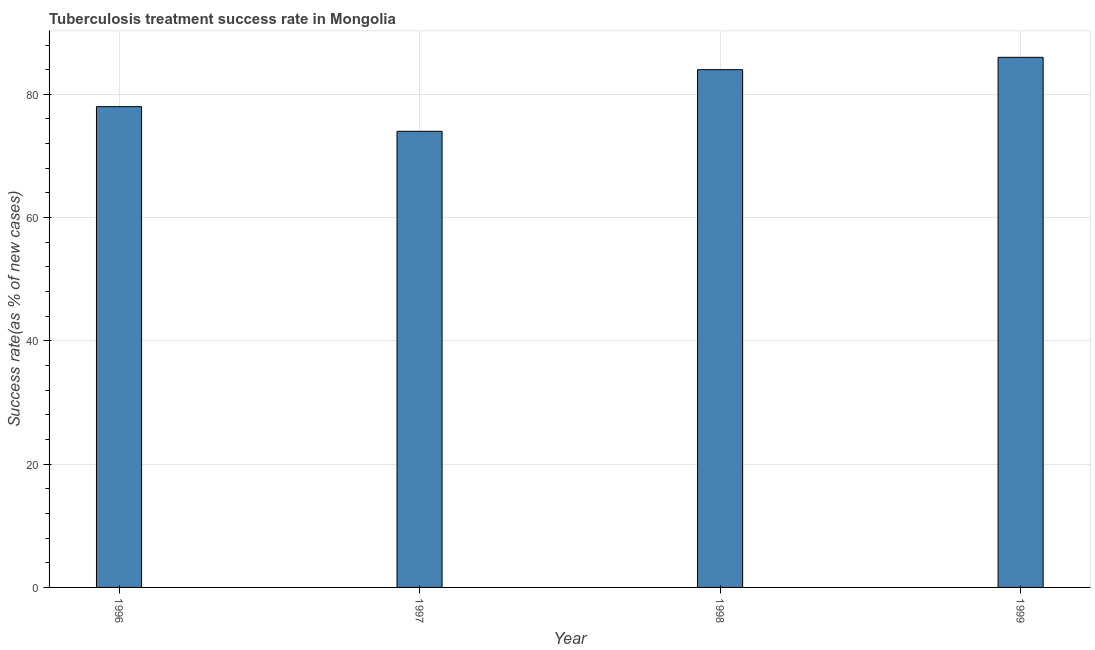Does the graph contain any zero values?
Ensure brevity in your answer.  No. Does the graph contain grids?
Ensure brevity in your answer.  Yes. What is the title of the graph?
Keep it short and to the point. Tuberculosis treatment success rate in Mongolia. What is the label or title of the X-axis?
Make the answer very short. Year. What is the label or title of the Y-axis?
Give a very brief answer. Success rate(as % of new cases). Across all years, what is the maximum tuberculosis treatment success rate?
Provide a succinct answer. 86. In which year was the tuberculosis treatment success rate maximum?
Offer a terse response. 1999. In which year was the tuberculosis treatment success rate minimum?
Your answer should be very brief. 1997. What is the sum of the tuberculosis treatment success rate?
Ensure brevity in your answer.  322. What is the median tuberculosis treatment success rate?
Provide a succinct answer. 81. Do a majority of the years between 1998 and 1996 (inclusive) have tuberculosis treatment success rate greater than 84 %?
Offer a very short reply. Yes. What is the ratio of the tuberculosis treatment success rate in 1998 to that in 1999?
Provide a succinct answer. 0.98. Is the tuberculosis treatment success rate in 1996 less than that in 1997?
Your response must be concise. No. In how many years, is the tuberculosis treatment success rate greater than the average tuberculosis treatment success rate taken over all years?
Ensure brevity in your answer.  2. How many years are there in the graph?
Offer a very short reply. 4. What is the Success rate(as % of new cases) in 1996?
Keep it short and to the point. 78. What is the Success rate(as % of new cases) of 1997?
Ensure brevity in your answer.  74. What is the difference between the Success rate(as % of new cases) in 1996 and 1998?
Provide a succinct answer. -6. What is the difference between the Success rate(as % of new cases) in 1997 and 1998?
Ensure brevity in your answer.  -10. What is the difference between the Success rate(as % of new cases) in 1997 and 1999?
Give a very brief answer. -12. What is the difference between the Success rate(as % of new cases) in 1998 and 1999?
Your answer should be compact. -2. What is the ratio of the Success rate(as % of new cases) in 1996 to that in 1997?
Your answer should be very brief. 1.05. What is the ratio of the Success rate(as % of new cases) in 1996 to that in 1998?
Ensure brevity in your answer.  0.93. What is the ratio of the Success rate(as % of new cases) in 1996 to that in 1999?
Your answer should be very brief. 0.91. What is the ratio of the Success rate(as % of new cases) in 1997 to that in 1998?
Keep it short and to the point. 0.88. What is the ratio of the Success rate(as % of new cases) in 1997 to that in 1999?
Offer a terse response. 0.86. 